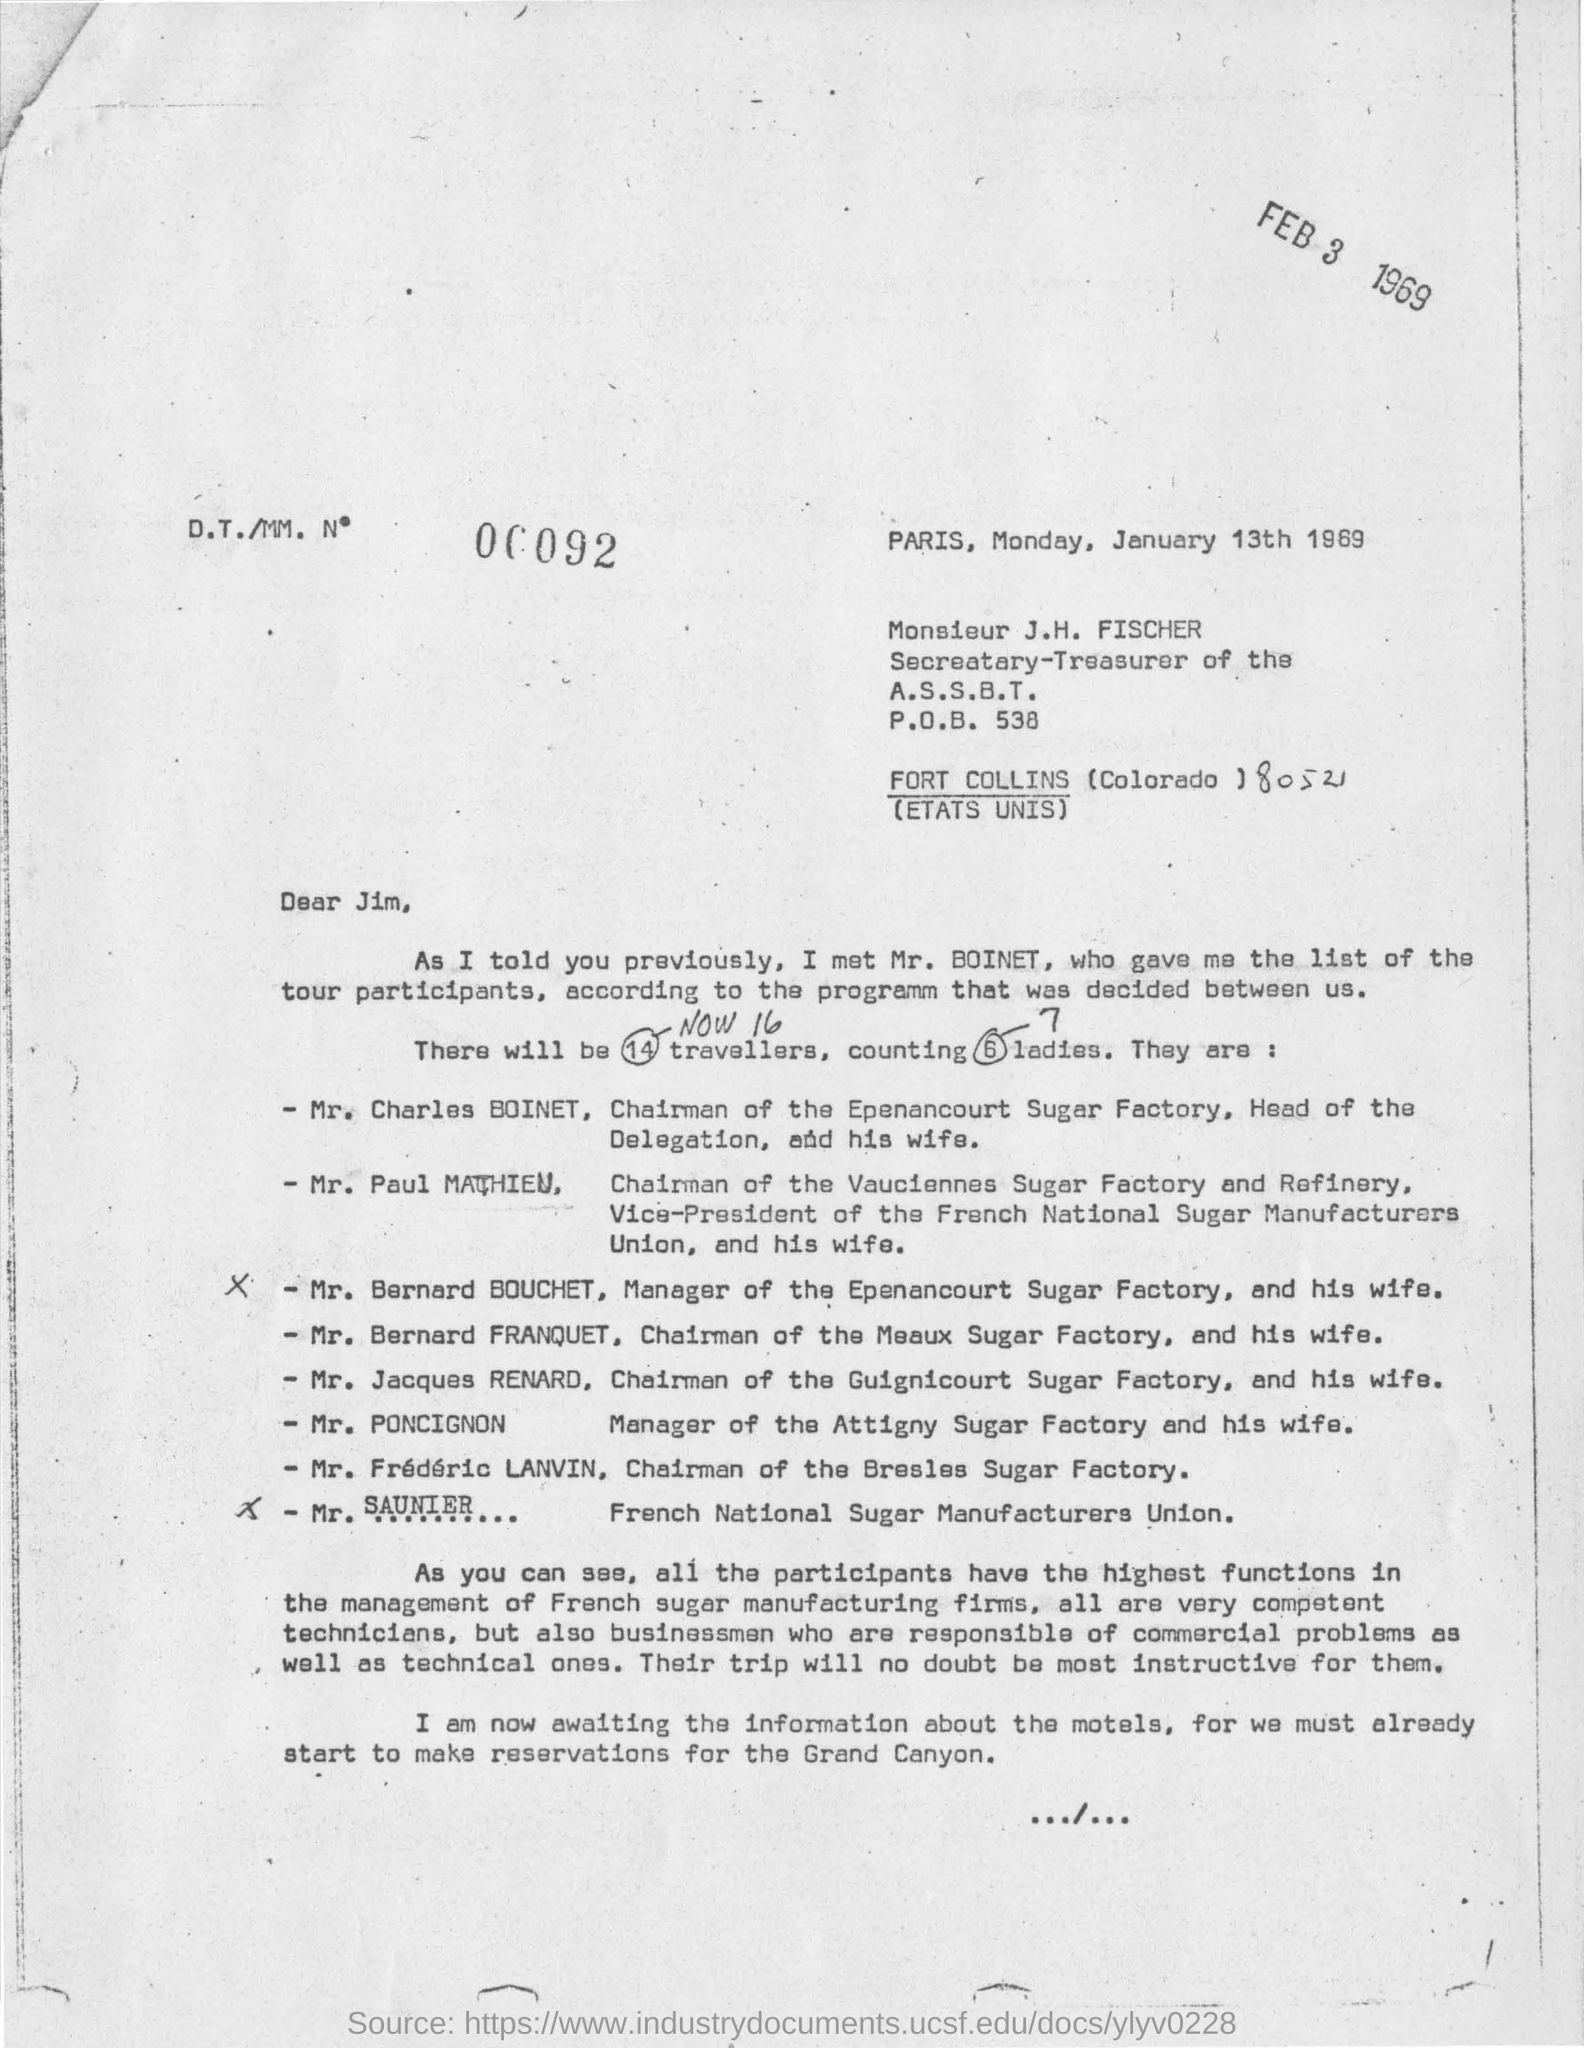Who is the secretary-treasurer of the A.S.S.B.T.?
Offer a very short reply. Monsieur J.H. Fischer. When is the letter written on?
Your response must be concise. January 13th 1969. Who gave the list of the tour participants?
Your answer should be very brief. Mr. Boinet. How many travellers are there for the tour?
Make the answer very short. 14. How many ladies are there among the 16 travellers?
Provide a succinct answer. 7. 